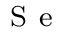<formula> <loc_0><loc_0><loc_500><loc_500>_ { S } e</formula> 